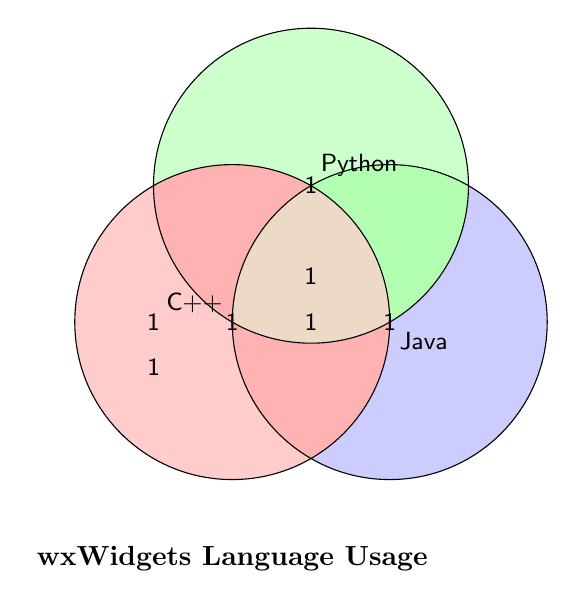What are the labels of the three circles? The labels are positioned next to each circle: "C++", "Python", and "Java".
Answer: "C++", "Python", "Java" What does the red-shaded area represent? The red-shaded area represents the usage of the C++ programming language.
Answer: C++ Which color represents the areas where multiple languages overlap? Areas where multiple languages overlap are shaded with a combination of their respective colors (e.g., brown for all three).
Answer: Brown How many regions are there where exactly two languages intersect? By counting the individual sections where exactly two circles overlap, we see three intersections: "C++ and Python", "C++ and Java", and "Python and Java".
Answer: 3 How many programming languages are used only by themselves and not with others? There are three single-programming-language use cases depicted in individual non-overlapping areas: one for C++, one for Python, and one for Java.
Answer: 3 In how many regions do all three languages overlap? The center where all three circles intersect is labeled "All three", meaning there is one region where all three languages overlap.
Answer: 1 Comparing the areas of overlap, which two languages share the most overlap? By observing the center-most region where all labels intersect, we can infer that all pairs of overlaps are represented equally (each overlap section is labeled with "1").
Answer: All equally What does the area labeled '1' between the C++ and Java circles signify? This area shows overlap between C++ and Java, meaning there is some usage of projects or applications that incorporate both languages.
Answer: C++ and Java Identify a region where Python is used in combination with another language but not all three. The regions labeled "C++ and Python" and "Python and Java" indicate Python's usage with another language but not in combination with all three.
Answer: C++ and Python, Python and Java Which region in the Venn diagram indicates the usage of all three languages? The central region overlapping all three circles is labeled with '1', representing the intersection where all three languages—C++, Python, and Java—are used together.
Answer: Center 